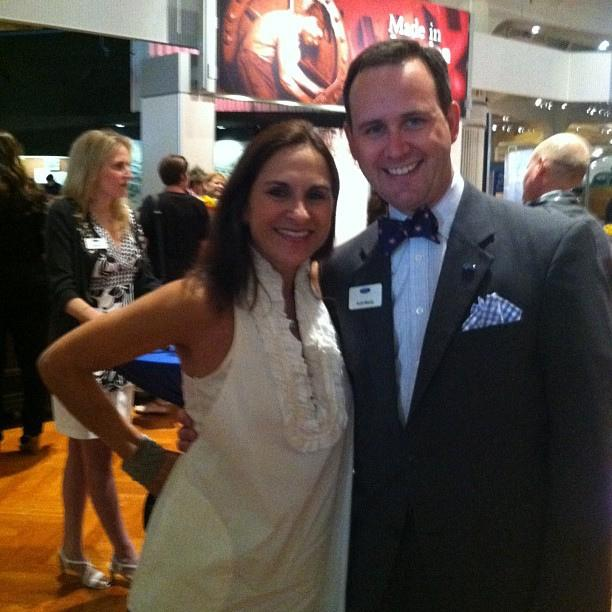At which event do these people pose? Please explain your reasoning. exhibition. Based on their clothes they are not at a zoo or a mall and there is no meeting taking place. 